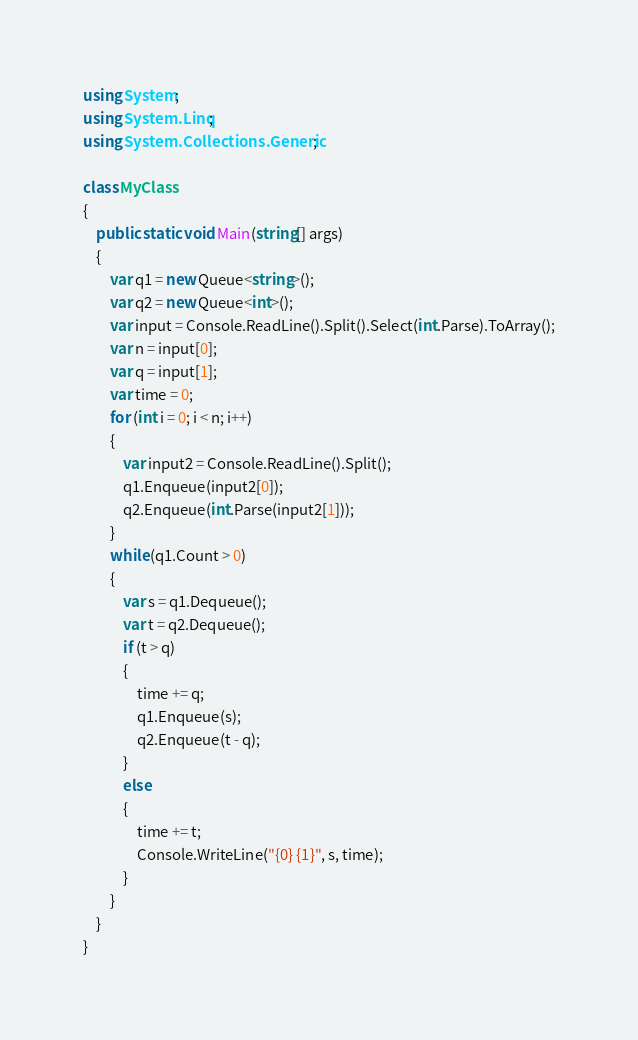Convert code to text. <code><loc_0><loc_0><loc_500><loc_500><_C#_>using System;
using System.Linq;
using System.Collections.Generic;

class MyClass
{
    public static void Main(string[] args)
    {
        var q1 = new Queue<string>();
        var q2 = new Queue<int>();
        var input = Console.ReadLine().Split().Select(int.Parse).ToArray();
        var n = input[0];
        var q = input[1];
        var time = 0;
        for (int i = 0; i < n; i++)
        {
            var input2 = Console.ReadLine().Split();
            q1.Enqueue(input2[0]);
            q2.Enqueue(int.Parse(input2[1]));
        }
        while (q1.Count > 0)
        {
            var s = q1.Dequeue();
            var t = q2.Dequeue();
            if (t > q)
            {
                time += q;
                q1.Enqueue(s);
                q2.Enqueue(t - q);
            }
            else
            {
                time += t;
                Console.WriteLine("{0} {1}", s, time);
            }
        }
    }
}
</code> 